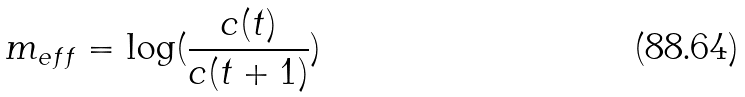Convert formula to latex. <formula><loc_0><loc_0><loc_500><loc_500>m _ { e f f } = \log ( \frac { c ( t ) } { c ( t + 1 ) } )</formula> 